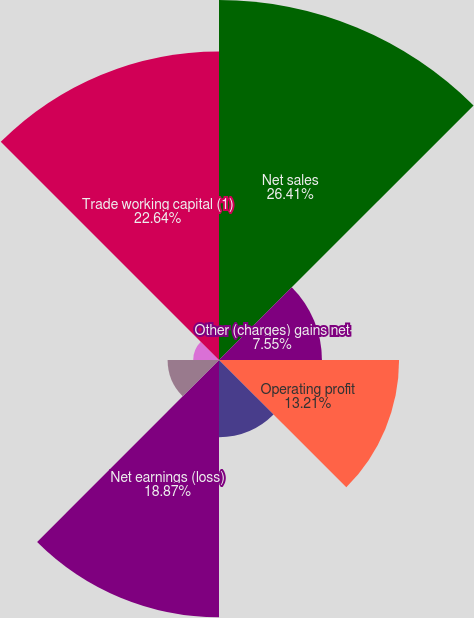<chart> <loc_0><loc_0><loc_500><loc_500><pie_chart><fcel>Net sales<fcel>Other (charges) gains net<fcel>Operating profit<fcel>Earnings (loss) from<fcel>Net earnings (loss)<fcel>Continuing operations - basic<fcel>Continuing operations -<fcel>Trade working capital (1)<nl><fcel>26.41%<fcel>7.55%<fcel>13.21%<fcel>5.66%<fcel>18.87%<fcel>3.77%<fcel>1.89%<fcel>22.64%<nl></chart> 